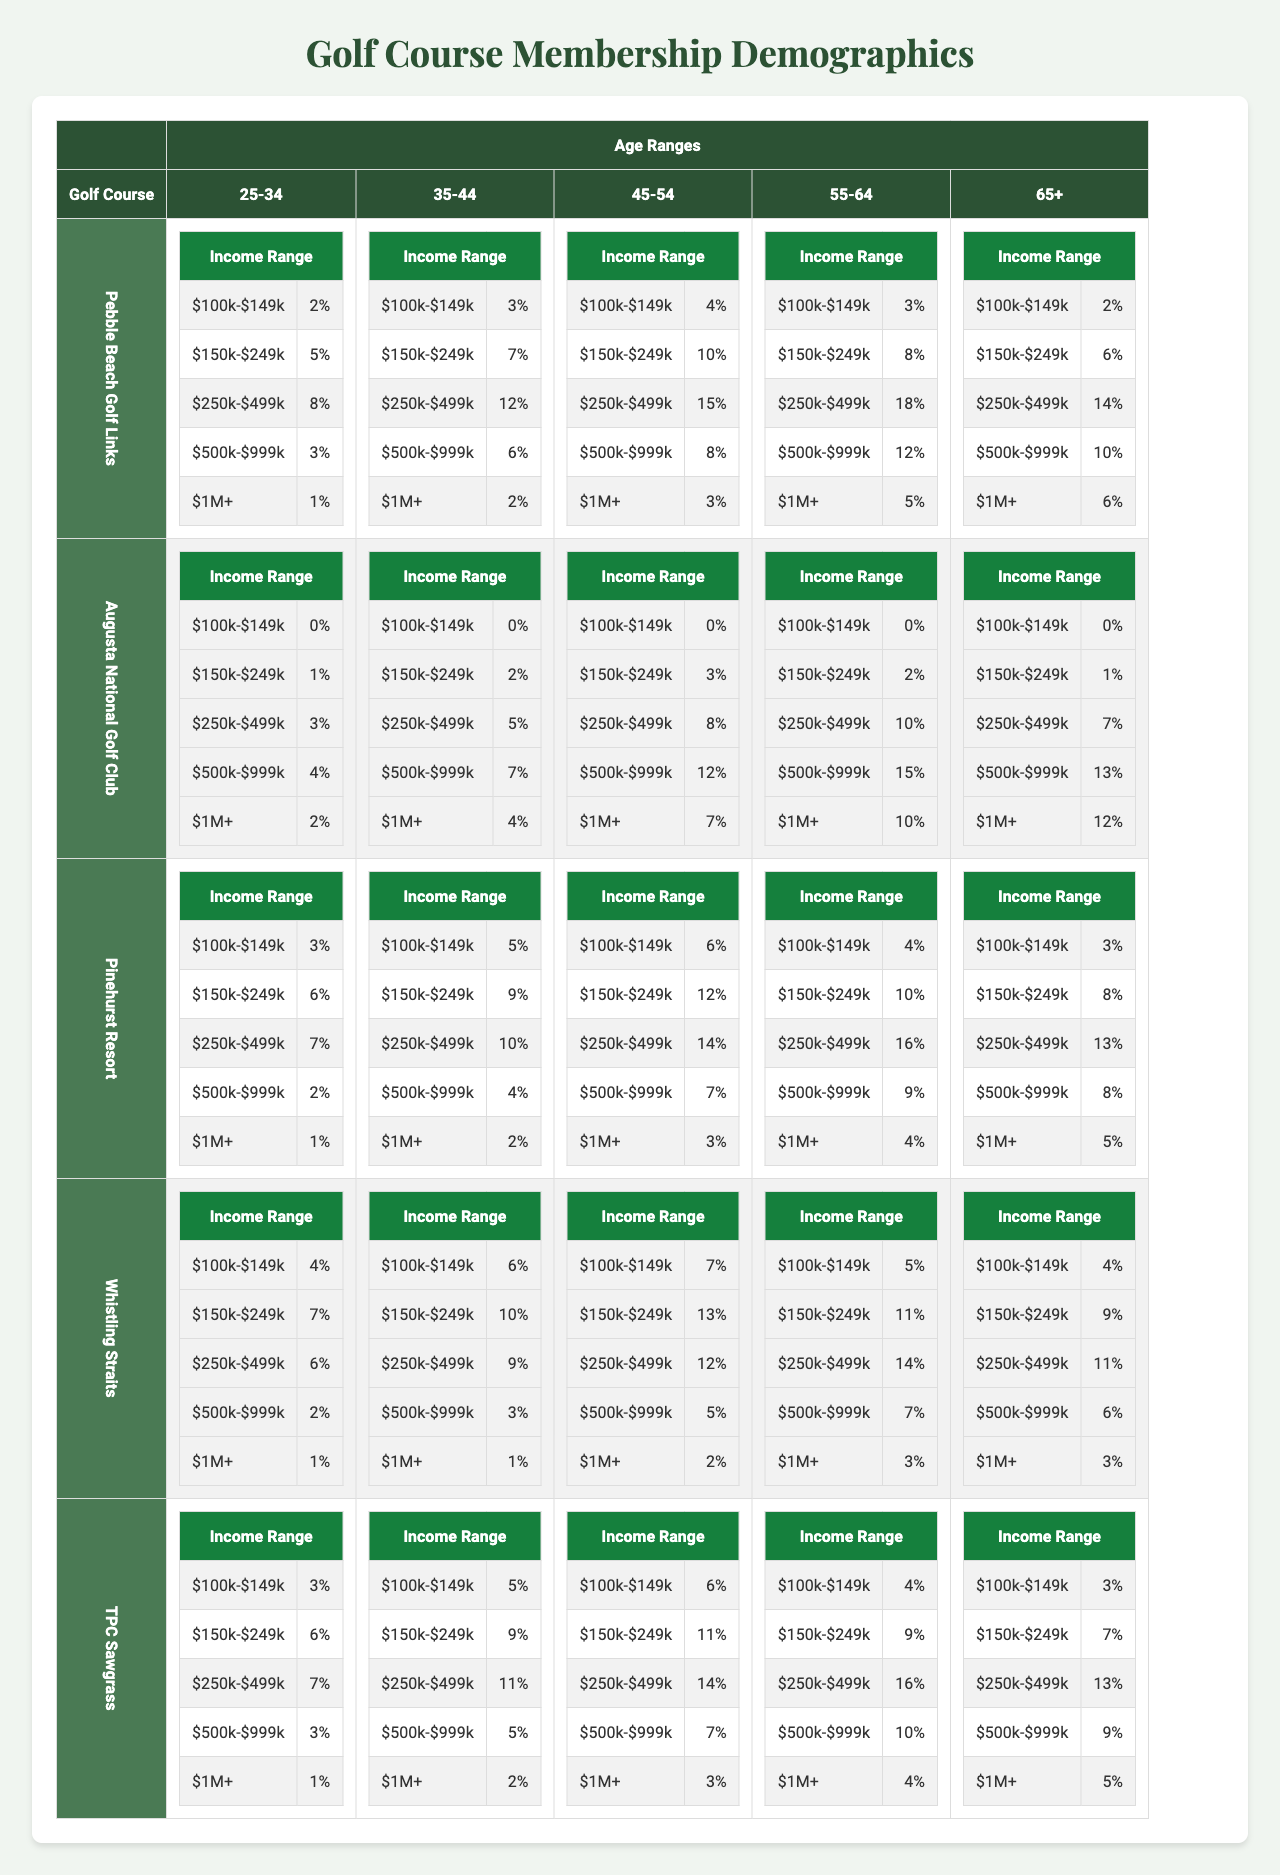What is the membership percentage of the 45-54 age group at TPC Sawgrass for the income range $250k-$499k? Looking at the TPC Sawgrass section of the table, under the 45-54 age group, the income range $250k-$499k shows a membership percentage of 14%.
Answer: 14% Which golf course has the highest membership percentage for the 35-44 age range in the income bracket of $500k-$999k? By checking the 35-44 age range across the golf courses, Augusta National Golf Club has the highest membership percentage of 7% in the $500k-$999k income category.
Answer: Augusta National Golf Club What is the total membership percentage for the income range $100k-$149k among all age groups at Pinehurst Resort? To find this, we add up the percentages for Pinehurst Resort under the income range $100k-$149k: 3% + 5% + 6% + 4% + 3% = 21%.
Answer: 21% Is there anyone in the 25-34 age group at Augusta National Golf Club with an income of $100k-$149k? No, according to the data under Augusta National Golf Club, the percentage for the 25-34 age group and income $100k-$149k is 0%.
Answer: No What is the average membership percentage of the 65+ age group across all golf courses for the income bracket of $1M+? For the 65+ age group and income $1M+, the percentages are: Pebble Beach (6%), Augusta National (12%), Pinehurst (5%), Whistling Straits (3%), and TPC Sawgrass (5%). The average is calculated as (6 + 12 + 5 + 3 + 5) / 5 = 31 / 5 = 6.2%.
Answer: 6.2% How many times higher is the membership percentage for the 55-64 age group in Whistling Straits for the income bracket $250k-$499k compared to Pebble Beach? At Whistling Straits, the percentage for the 55-64 age group and income $250k-$499k is 14%, while at Pebble Beach, it is 18%. The proportion is 14% / 18% = 0.778 or approximately 0.78 times lower.
Answer: 0.78 Which age group at Pinehurst Resort has the lowest membership percentage for the income range $500k-$999k? To find this, we compare the percentages: 2% (25-34), 4% (35-44), 7% (45-54), 9% (55-64), and 8% (65+). The lowest is 2% in the 25-34 age group.
Answer: 25-34 age group What is the overall highest membership percentage across all golf courses for the income range $250k-$499k among members aged 55-64? Between the golf courses for the age 55-64 in the $250k-$499k income range: Pebble Beach (18%), Augusta National (10%), Pinehurst (16%), Whistling Straits (14%), TPC Sawgrass (16%). The highest is 18% at Pebble Beach.
Answer: 18% What percentage of the 25-34 age group earns over $1M at TPC Sawgrass? TPC Sawgrass has a membership percentage of 1% for the 25-34 age group in the $1M+ income range.
Answer: 1% 